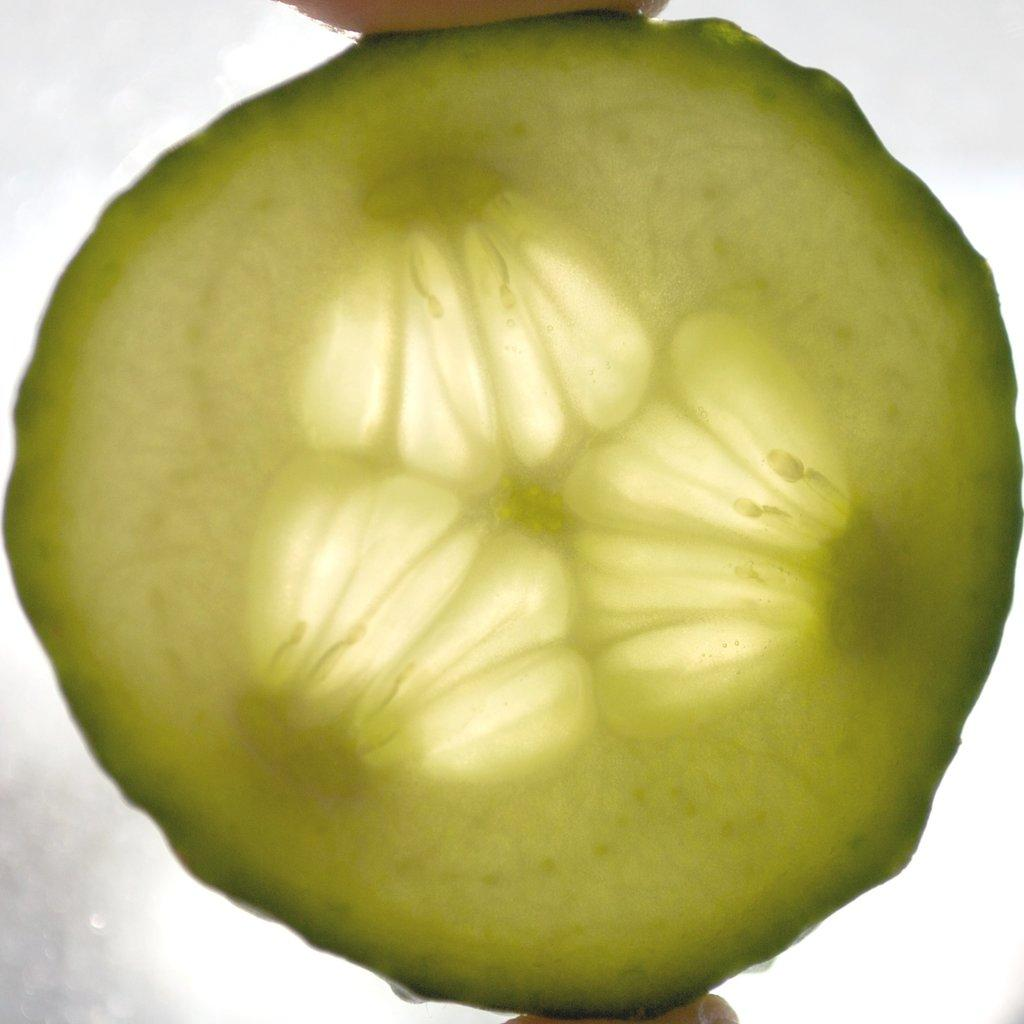What is the main subject of the image? There is a person in the image. What is the person holding in the image? The person is holding a cucumber piece. How is the cucumber piece shaped? The cucumber piece is in a circle shape. How is the person holding the cucumber piece? The person is holding the cucumber piece with two fingers. What color is the background of the image? The background of the image is white. What type of toothpaste is being used to draw the circle shape on the person's face in the image? There is no toothpaste or drawing on the person's face in the image; the cucumber piece is simply in a circle shape. How many flies can be seen buzzing around the person in the image? There are no flies present in the image. 